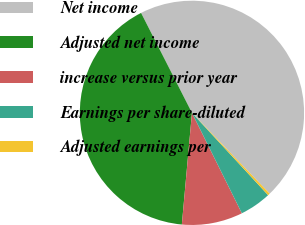Convert chart to OTSL. <chart><loc_0><loc_0><loc_500><loc_500><pie_chart><fcel>Net income<fcel>Adjusted net income<fcel>increase versus prior year<fcel>Earnings per share-diluted<fcel>Adjusted earnings per<nl><fcel>45.31%<fcel>41.07%<fcel>8.78%<fcel>4.54%<fcel>0.31%<nl></chart> 